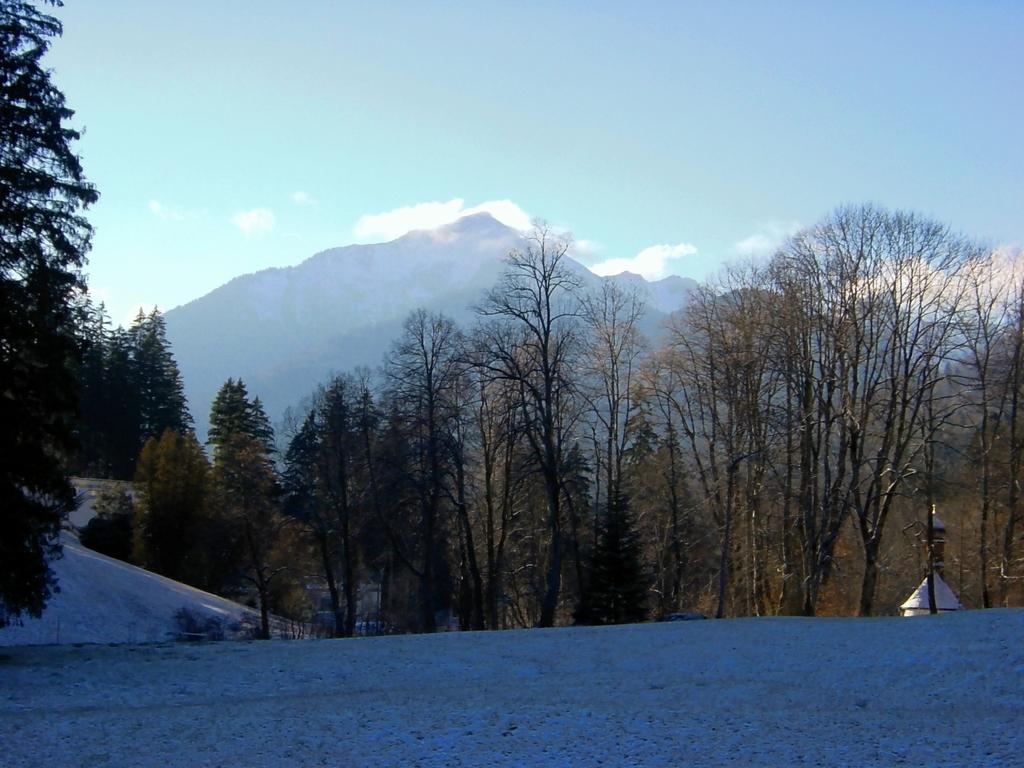What is the main feature in the foreground of the image? There is an empty land in the foreground of the image. What type of vegetation can be seen in the image? There are trees visible in the image. What geographical feature can be seen in the background of the image? There are mountains visible in the image. What type of bone is buried in the empty land in the image? There is no bone present in the image; it is an empty land with no visible objects or features besides the trees and mountains. 